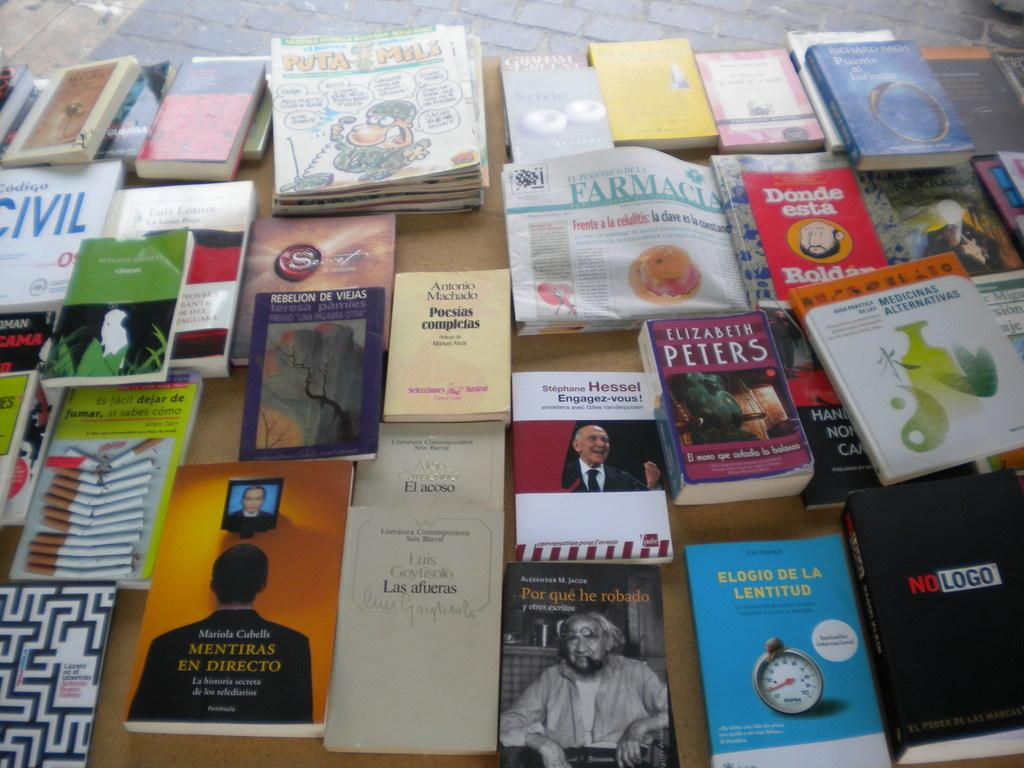<image>
Offer a succinct explanation of the picture presented. A lot of books placed somewhere with one being titled "No Logo". 